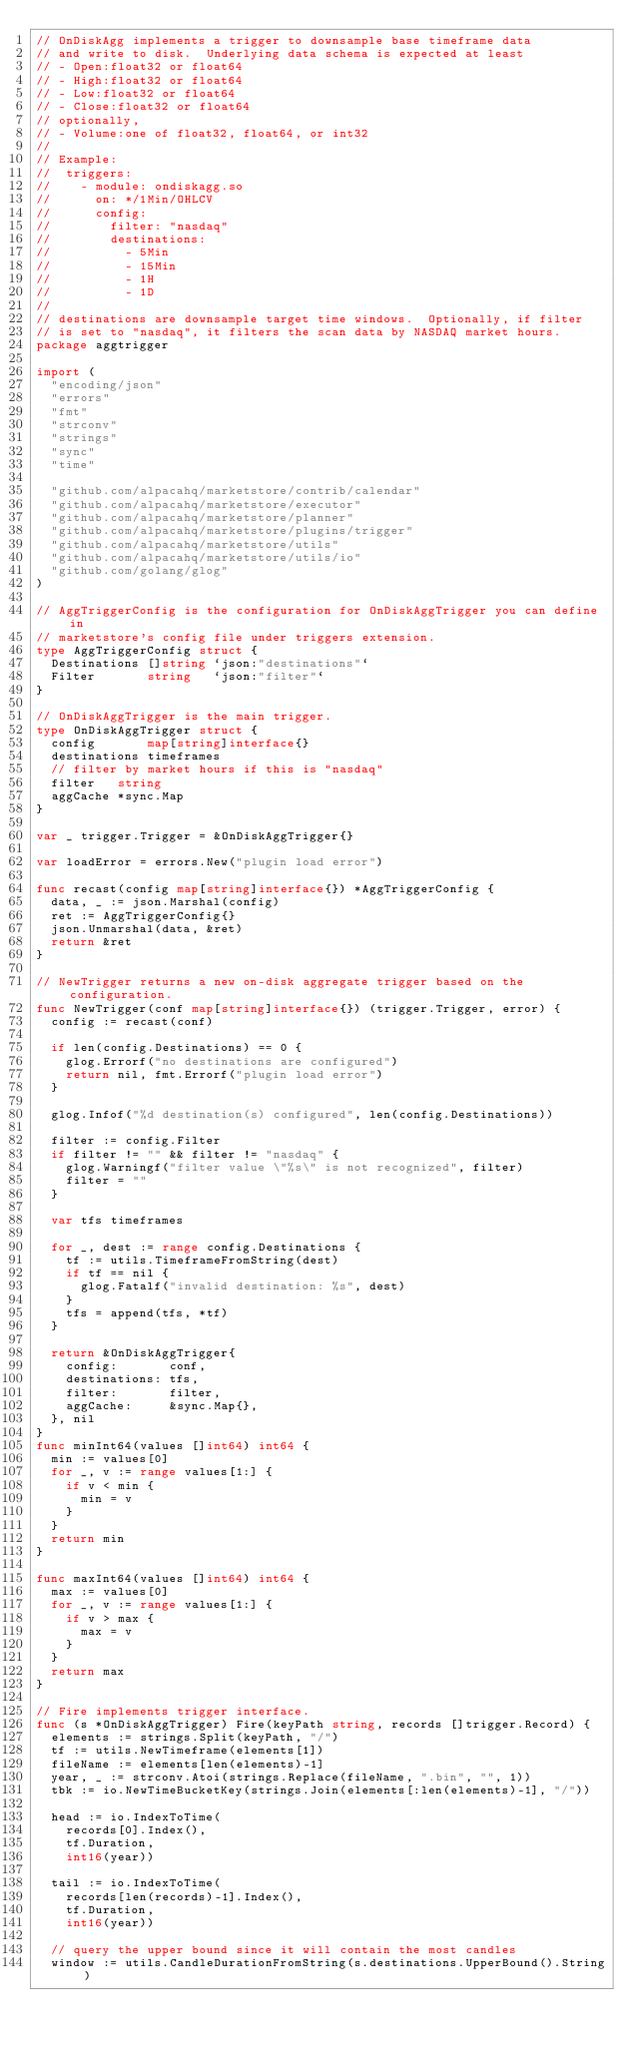<code> <loc_0><loc_0><loc_500><loc_500><_Go_>// OnDiskAgg implements a trigger to downsample base timeframe data
// and write to disk.  Underlying data schema is expected at least
// - Open:float32 or float64
// - High:float32 or float64
// - Low:float32 or float64
// - Close:float32 or float64
// optionally,
// - Volume:one of float32, float64, or int32
//
// Example:
// 	triggers:
// 	  - module: ondiskagg.so
// 	    on: */1Min/OHLCV
// 	    config:
// 	      filter: "nasdaq"
// 	      destinations:
// 	        - 5Min
// 	        - 15Min
// 	        - 1H
// 	        - 1D
//
// destinations are downsample target time windows.  Optionally, if filter
// is set to "nasdaq", it filters the scan data by NASDAQ market hours.
package aggtrigger

import (
	"encoding/json"
	"errors"
	"fmt"
	"strconv"
	"strings"
	"sync"
	"time"

	"github.com/alpacahq/marketstore/contrib/calendar"
	"github.com/alpacahq/marketstore/executor"
	"github.com/alpacahq/marketstore/planner"
	"github.com/alpacahq/marketstore/plugins/trigger"
	"github.com/alpacahq/marketstore/utils"
	"github.com/alpacahq/marketstore/utils/io"
	"github.com/golang/glog"
)

// AggTriggerConfig is the configuration for OnDiskAggTrigger you can define in
// marketstore's config file under triggers extension.
type AggTriggerConfig struct {
	Destinations []string `json:"destinations"`
	Filter       string   `json:"filter"`
}

// OnDiskAggTrigger is the main trigger.
type OnDiskAggTrigger struct {
	config       map[string]interface{}
	destinations timeframes
	// filter by market hours if this is "nasdaq"
	filter   string
	aggCache *sync.Map
}

var _ trigger.Trigger = &OnDiskAggTrigger{}

var loadError = errors.New("plugin load error")

func recast(config map[string]interface{}) *AggTriggerConfig {
	data, _ := json.Marshal(config)
	ret := AggTriggerConfig{}
	json.Unmarshal(data, &ret)
	return &ret
}

// NewTrigger returns a new on-disk aggregate trigger based on the configuration.
func NewTrigger(conf map[string]interface{}) (trigger.Trigger, error) {
	config := recast(conf)

	if len(config.Destinations) == 0 {
		glog.Errorf("no destinations are configured")
		return nil, fmt.Errorf("plugin load error")
	}

	glog.Infof("%d destination(s) configured", len(config.Destinations))

	filter := config.Filter
	if filter != "" && filter != "nasdaq" {
		glog.Warningf("filter value \"%s\" is not recognized", filter)
		filter = ""
	}

	var tfs timeframes

	for _, dest := range config.Destinations {
		tf := utils.TimeframeFromString(dest)
		if tf == nil {
			glog.Fatalf("invalid destination: %s", dest)
		}
		tfs = append(tfs, *tf)
	}

	return &OnDiskAggTrigger{
		config:       conf,
		destinations: tfs,
		filter:       filter,
		aggCache:     &sync.Map{},
	}, nil
}
func minInt64(values []int64) int64 {
	min := values[0]
	for _, v := range values[1:] {
		if v < min {
			min = v
		}
	}
	return min
}

func maxInt64(values []int64) int64 {
	max := values[0]
	for _, v := range values[1:] {
		if v > max {
			max = v
		}
	}
	return max
}

// Fire implements trigger interface.
func (s *OnDiskAggTrigger) Fire(keyPath string, records []trigger.Record) {
	elements := strings.Split(keyPath, "/")
	tf := utils.NewTimeframe(elements[1])
	fileName := elements[len(elements)-1]
	year, _ := strconv.Atoi(strings.Replace(fileName, ".bin", "", 1))
	tbk := io.NewTimeBucketKey(strings.Join(elements[:len(elements)-1], "/"))

	head := io.IndexToTime(
		records[0].Index(),
		tf.Duration,
		int16(year))

	tail := io.IndexToTime(
		records[len(records)-1].Index(),
		tf.Duration,
		int16(year))

	// query the upper bound since it will contain the most candles
	window := utils.CandleDurationFromString(s.destinations.UpperBound().String)
</code> 